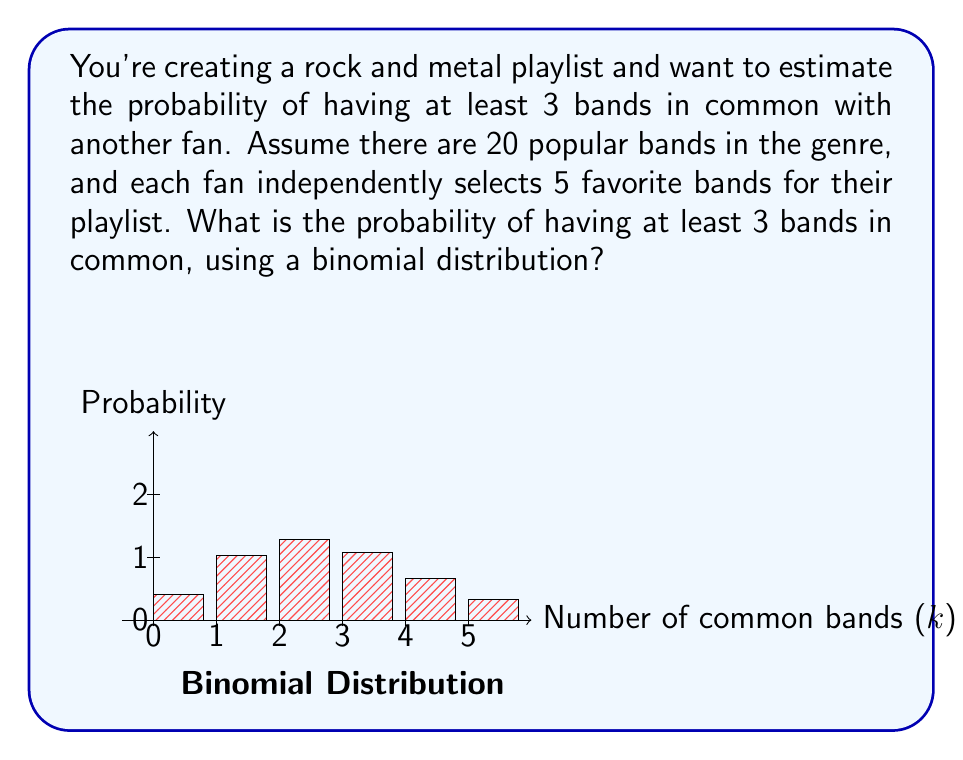Help me with this question. Let's approach this step-by-step:

1) First, we need to identify the parameters of our binomial distribution:
   - $n$ = 5 (number of trials, as we're selecting 5 bands)
   - $p$ = probability of selecting a common band in a single trial

2) To calculate $p$, we need to use the hypergeometric probability:
   $p = \frac{\binom{5}{1}}{\binom{20}{1}} = \frac{5}{20} = 0.25$

3) Now, we want the probability of having at least 3 bands in common. This means we need to sum the probabilities of having 3, 4, or 5 bands in common.

4) The probability mass function for a binomial distribution is:
   $P(X = k) = \binom{n}{k} p^k (1-p)^{n-k}$

5) Let's calculate for k = 3, 4, and 5:

   For k = 3:
   $P(X = 3) = \binom{5}{3} (0.25)^3 (0.75)^2 = 10 * 0.015625 * 0.5625 = 0.0878906$

   For k = 4:
   $P(X = 4) = \binom{5}{4} (0.25)^4 (0.75)^1 = 5 * 0.00390625 * 0.75 = 0.0146484$

   For k = 5:
   $P(X = 5) = \binom{5}{5} (0.25)^5 (0.75)^0 = 1 * 0.0009765625 * 1 = 0.0009765625$

6) The probability of having at least 3 bands in common is the sum of these probabilities:
   $P(X \geq 3) = P(X = 3) + P(X = 4) + P(X = 5)$
                $= 0.0878906 + 0.0146484 + 0.0009765625$
                $= 0.1035156$

Therefore, the probability of having at least 3 bands in common is approximately 0.1035 or 10.35%.
Answer: 0.1035 or 10.35% 